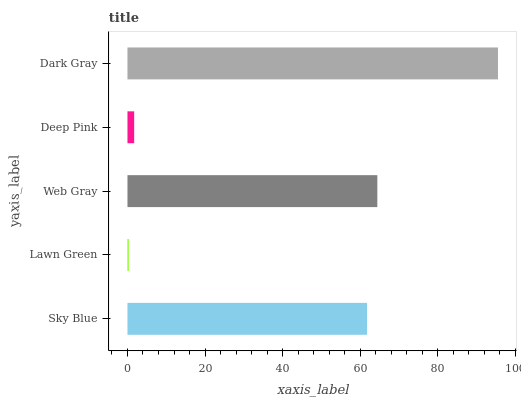Is Lawn Green the minimum?
Answer yes or no. Yes. Is Dark Gray the maximum?
Answer yes or no. Yes. Is Web Gray the minimum?
Answer yes or no. No. Is Web Gray the maximum?
Answer yes or no. No. Is Web Gray greater than Lawn Green?
Answer yes or no. Yes. Is Lawn Green less than Web Gray?
Answer yes or no. Yes. Is Lawn Green greater than Web Gray?
Answer yes or no. No. Is Web Gray less than Lawn Green?
Answer yes or no. No. Is Sky Blue the high median?
Answer yes or no. Yes. Is Sky Blue the low median?
Answer yes or no. Yes. Is Dark Gray the high median?
Answer yes or no. No. Is Web Gray the low median?
Answer yes or no. No. 